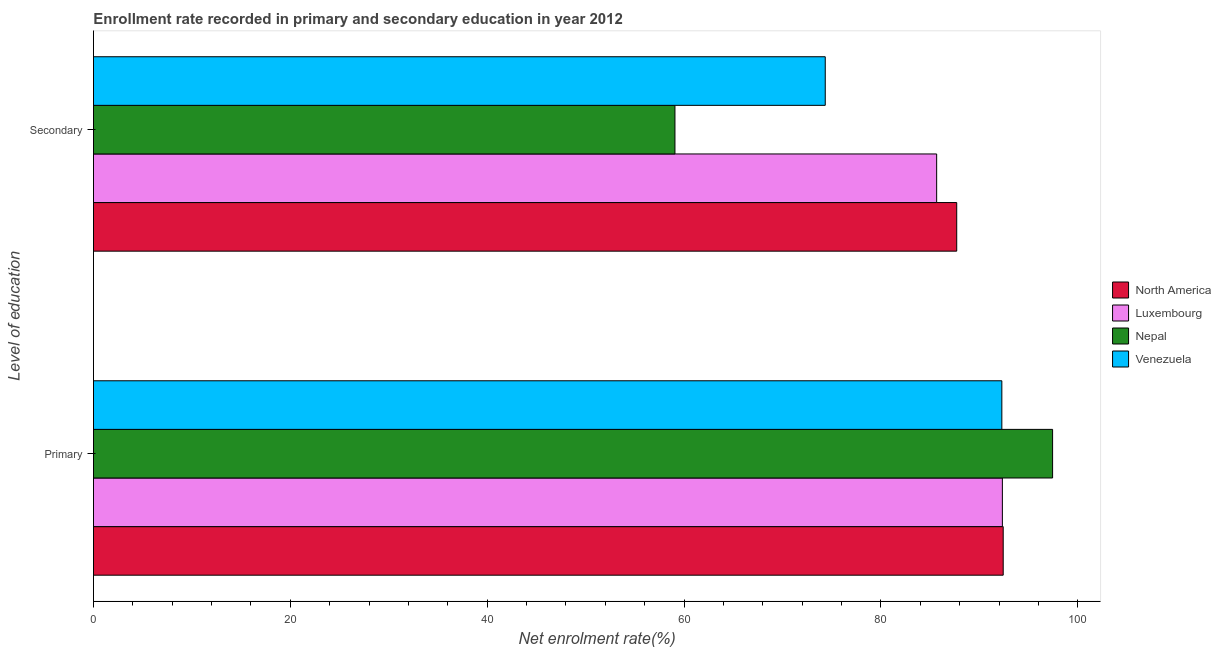Are the number of bars per tick equal to the number of legend labels?
Your answer should be compact. Yes. Are the number of bars on each tick of the Y-axis equal?
Provide a short and direct response. Yes. How many bars are there on the 2nd tick from the top?
Ensure brevity in your answer.  4. What is the label of the 2nd group of bars from the top?
Ensure brevity in your answer.  Primary. What is the enrollment rate in secondary education in Nepal?
Give a very brief answer. 59.07. Across all countries, what is the maximum enrollment rate in primary education?
Provide a short and direct response. 97.43. Across all countries, what is the minimum enrollment rate in secondary education?
Keep it short and to the point. 59.07. In which country was the enrollment rate in primary education maximum?
Keep it short and to the point. Nepal. In which country was the enrollment rate in secondary education minimum?
Your response must be concise. Nepal. What is the total enrollment rate in secondary education in the graph?
Offer a very short reply. 306.76. What is the difference between the enrollment rate in secondary education in Luxembourg and that in Nepal?
Your answer should be very brief. 26.58. What is the difference between the enrollment rate in secondary education in Luxembourg and the enrollment rate in primary education in Nepal?
Provide a succinct answer. -11.78. What is the average enrollment rate in secondary education per country?
Keep it short and to the point. 76.69. What is the difference between the enrollment rate in secondary education and enrollment rate in primary education in Luxembourg?
Keep it short and to the point. -6.68. What is the ratio of the enrollment rate in secondary education in Nepal to that in North America?
Make the answer very short. 0.67. What does the 2nd bar from the bottom in Primary represents?
Provide a succinct answer. Luxembourg. How many bars are there?
Provide a short and direct response. 8. Does the graph contain any zero values?
Give a very brief answer. No. Does the graph contain grids?
Your answer should be very brief. No. Where does the legend appear in the graph?
Your response must be concise. Center right. What is the title of the graph?
Offer a very short reply. Enrollment rate recorded in primary and secondary education in year 2012. What is the label or title of the X-axis?
Your answer should be very brief. Net enrolment rate(%). What is the label or title of the Y-axis?
Offer a very short reply. Level of education. What is the Net enrolment rate(%) in North America in Primary?
Provide a short and direct response. 92.42. What is the Net enrolment rate(%) in Luxembourg in Primary?
Offer a terse response. 92.33. What is the Net enrolment rate(%) in Nepal in Primary?
Offer a terse response. 97.43. What is the Net enrolment rate(%) of Venezuela in Primary?
Make the answer very short. 92.28. What is the Net enrolment rate(%) in North America in Secondary?
Offer a very short reply. 87.69. What is the Net enrolment rate(%) in Luxembourg in Secondary?
Make the answer very short. 85.65. What is the Net enrolment rate(%) in Nepal in Secondary?
Keep it short and to the point. 59.07. What is the Net enrolment rate(%) in Venezuela in Secondary?
Offer a very short reply. 74.34. Across all Level of education, what is the maximum Net enrolment rate(%) of North America?
Make the answer very short. 92.42. Across all Level of education, what is the maximum Net enrolment rate(%) of Luxembourg?
Make the answer very short. 92.33. Across all Level of education, what is the maximum Net enrolment rate(%) of Nepal?
Provide a short and direct response. 97.43. Across all Level of education, what is the maximum Net enrolment rate(%) of Venezuela?
Keep it short and to the point. 92.28. Across all Level of education, what is the minimum Net enrolment rate(%) in North America?
Keep it short and to the point. 87.69. Across all Level of education, what is the minimum Net enrolment rate(%) in Luxembourg?
Your answer should be compact. 85.65. Across all Level of education, what is the minimum Net enrolment rate(%) in Nepal?
Keep it short and to the point. 59.07. Across all Level of education, what is the minimum Net enrolment rate(%) of Venezuela?
Your answer should be compact. 74.34. What is the total Net enrolment rate(%) of North America in the graph?
Your response must be concise. 180.11. What is the total Net enrolment rate(%) in Luxembourg in the graph?
Make the answer very short. 177.98. What is the total Net enrolment rate(%) of Nepal in the graph?
Your answer should be compact. 156.5. What is the total Net enrolment rate(%) in Venezuela in the graph?
Your answer should be very brief. 166.62. What is the difference between the Net enrolment rate(%) of North America in Primary and that in Secondary?
Offer a terse response. 4.72. What is the difference between the Net enrolment rate(%) in Luxembourg in Primary and that in Secondary?
Your answer should be very brief. 6.68. What is the difference between the Net enrolment rate(%) in Nepal in Primary and that in Secondary?
Keep it short and to the point. 38.36. What is the difference between the Net enrolment rate(%) in Venezuela in Primary and that in Secondary?
Keep it short and to the point. 17.94. What is the difference between the Net enrolment rate(%) in North America in Primary and the Net enrolment rate(%) in Luxembourg in Secondary?
Your answer should be compact. 6.76. What is the difference between the Net enrolment rate(%) of North America in Primary and the Net enrolment rate(%) of Nepal in Secondary?
Offer a terse response. 33.34. What is the difference between the Net enrolment rate(%) of North America in Primary and the Net enrolment rate(%) of Venezuela in Secondary?
Keep it short and to the point. 18.08. What is the difference between the Net enrolment rate(%) of Luxembourg in Primary and the Net enrolment rate(%) of Nepal in Secondary?
Make the answer very short. 33.26. What is the difference between the Net enrolment rate(%) in Luxembourg in Primary and the Net enrolment rate(%) in Venezuela in Secondary?
Give a very brief answer. 17.99. What is the difference between the Net enrolment rate(%) of Nepal in Primary and the Net enrolment rate(%) of Venezuela in Secondary?
Keep it short and to the point. 23.09. What is the average Net enrolment rate(%) of North America per Level of education?
Make the answer very short. 90.05. What is the average Net enrolment rate(%) in Luxembourg per Level of education?
Provide a short and direct response. 88.99. What is the average Net enrolment rate(%) of Nepal per Level of education?
Your answer should be very brief. 78.25. What is the average Net enrolment rate(%) in Venezuela per Level of education?
Provide a short and direct response. 83.31. What is the difference between the Net enrolment rate(%) of North America and Net enrolment rate(%) of Luxembourg in Primary?
Make the answer very short. 0.08. What is the difference between the Net enrolment rate(%) in North America and Net enrolment rate(%) in Nepal in Primary?
Your response must be concise. -5.02. What is the difference between the Net enrolment rate(%) in North America and Net enrolment rate(%) in Venezuela in Primary?
Provide a succinct answer. 0.14. What is the difference between the Net enrolment rate(%) in Luxembourg and Net enrolment rate(%) in Nepal in Primary?
Provide a succinct answer. -5.1. What is the difference between the Net enrolment rate(%) in Luxembourg and Net enrolment rate(%) in Venezuela in Primary?
Give a very brief answer. 0.05. What is the difference between the Net enrolment rate(%) in Nepal and Net enrolment rate(%) in Venezuela in Primary?
Make the answer very short. 5.16. What is the difference between the Net enrolment rate(%) of North America and Net enrolment rate(%) of Luxembourg in Secondary?
Provide a succinct answer. 2.04. What is the difference between the Net enrolment rate(%) of North America and Net enrolment rate(%) of Nepal in Secondary?
Make the answer very short. 28.62. What is the difference between the Net enrolment rate(%) in North America and Net enrolment rate(%) in Venezuela in Secondary?
Keep it short and to the point. 13.35. What is the difference between the Net enrolment rate(%) of Luxembourg and Net enrolment rate(%) of Nepal in Secondary?
Offer a terse response. 26.58. What is the difference between the Net enrolment rate(%) in Luxembourg and Net enrolment rate(%) in Venezuela in Secondary?
Provide a short and direct response. 11.32. What is the difference between the Net enrolment rate(%) of Nepal and Net enrolment rate(%) of Venezuela in Secondary?
Offer a very short reply. -15.27. What is the ratio of the Net enrolment rate(%) of North America in Primary to that in Secondary?
Offer a terse response. 1.05. What is the ratio of the Net enrolment rate(%) of Luxembourg in Primary to that in Secondary?
Your response must be concise. 1.08. What is the ratio of the Net enrolment rate(%) of Nepal in Primary to that in Secondary?
Offer a terse response. 1.65. What is the ratio of the Net enrolment rate(%) of Venezuela in Primary to that in Secondary?
Provide a succinct answer. 1.24. What is the difference between the highest and the second highest Net enrolment rate(%) in North America?
Keep it short and to the point. 4.72. What is the difference between the highest and the second highest Net enrolment rate(%) of Luxembourg?
Ensure brevity in your answer.  6.68. What is the difference between the highest and the second highest Net enrolment rate(%) of Nepal?
Offer a terse response. 38.36. What is the difference between the highest and the second highest Net enrolment rate(%) in Venezuela?
Offer a terse response. 17.94. What is the difference between the highest and the lowest Net enrolment rate(%) of North America?
Give a very brief answer. 4.72. What is the difference between the highest and the lowest Net enrolment rate(%) in Luxembourg?
Keep it short and to the point. 6.68. What is the difference between the highest and the lowest Net enrolment rate(%) in Nepal?
Make the answer very short. 38.36. What is the difference between the highest and the lowest Net enrolment rate(%) in Venezuela?
Give a very brief answer. 17.94. 